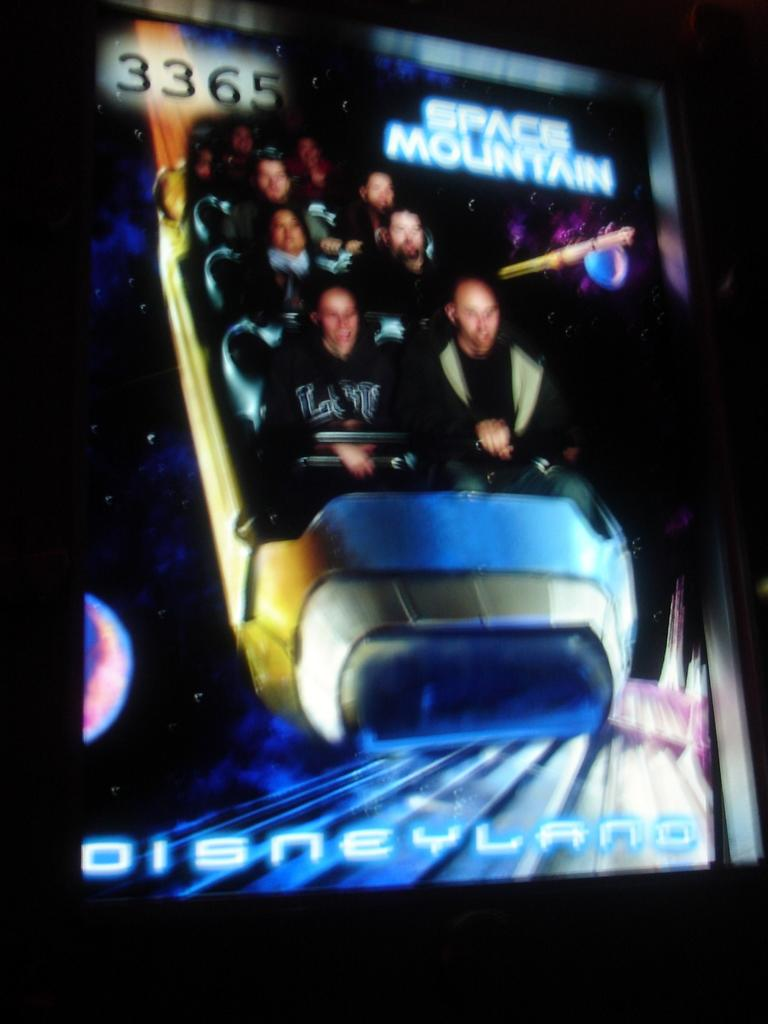What is located in the center of the image? There is a poster in the center of the image. What does the poster depict? The poster depicts people in a train. What type of root can be seen growing from the train in the image? There is no root growing from the train in the image; the poster depicts people in a train. 